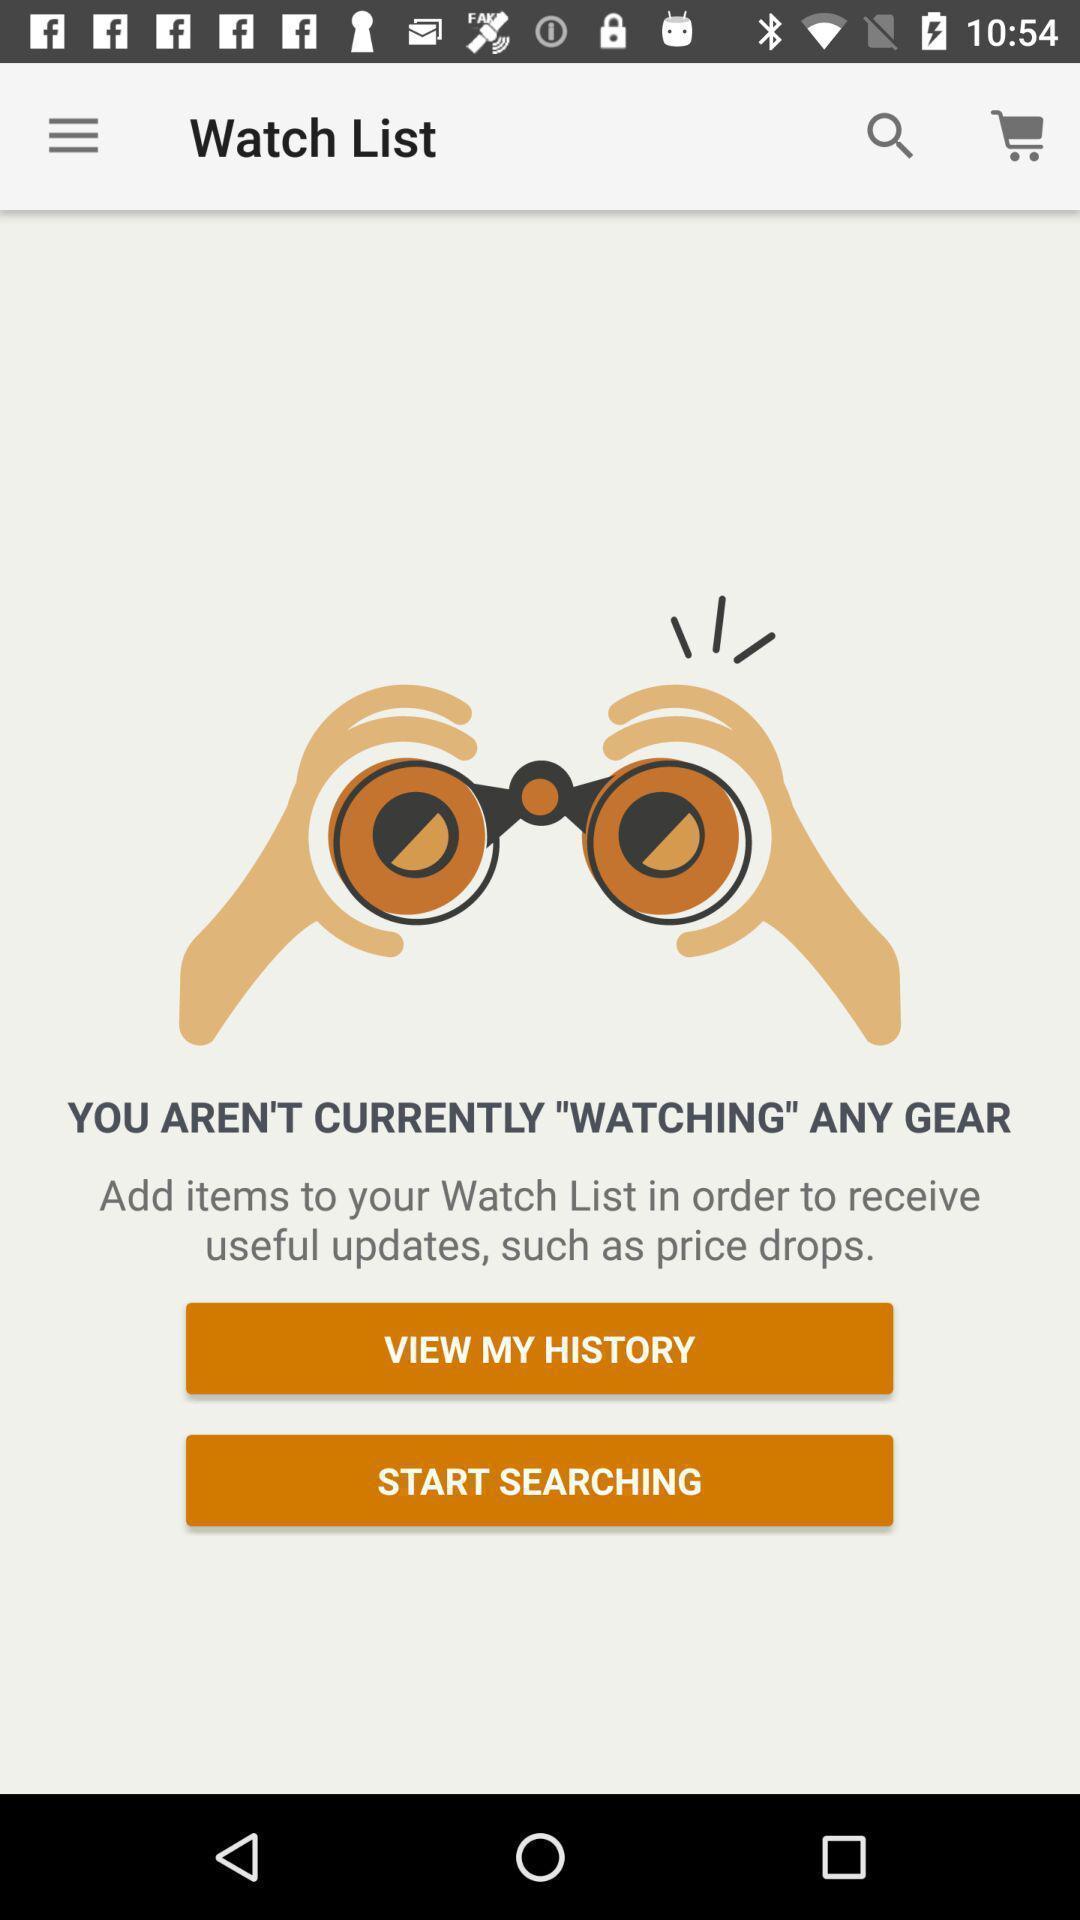Describe this image in words. Page displaying the watch list of the app. 